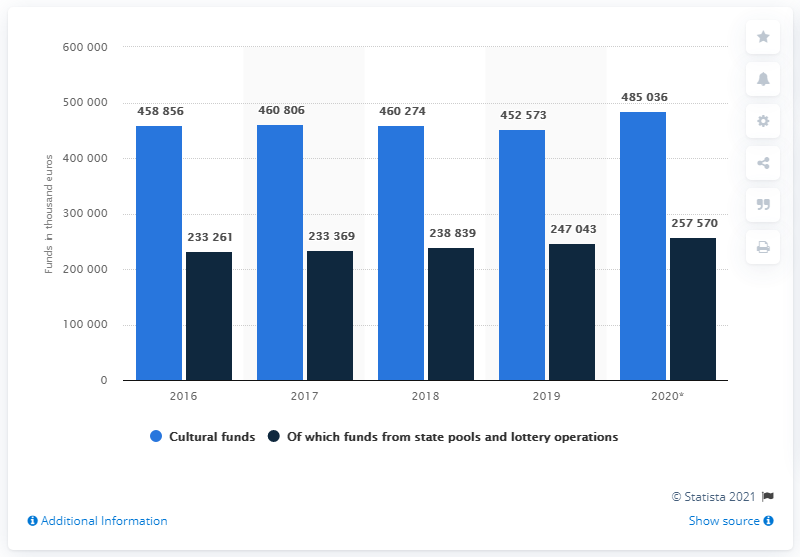Outline some significant characteristics in this image. In 2020, the cultural fund recorded the highest value. In 2019, the amount of cultural funds available was minimal. 